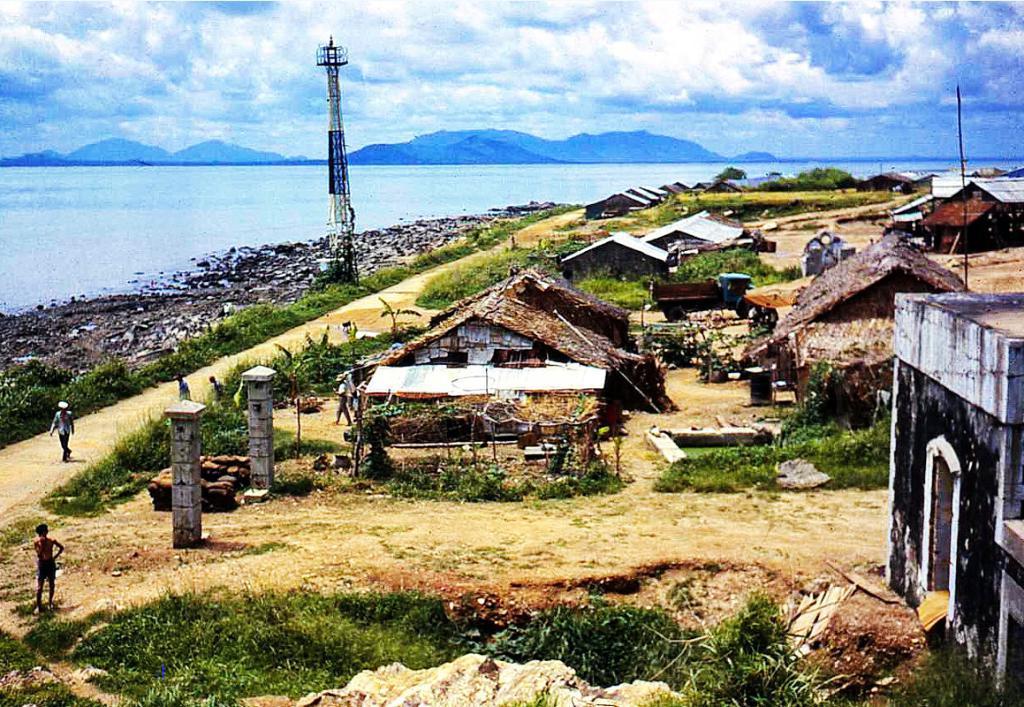Describe this image in one or two sentences. In this image there are people walking on a path and there are houses, plants and a tower, in the background there is the sea, mountain and the sky. 